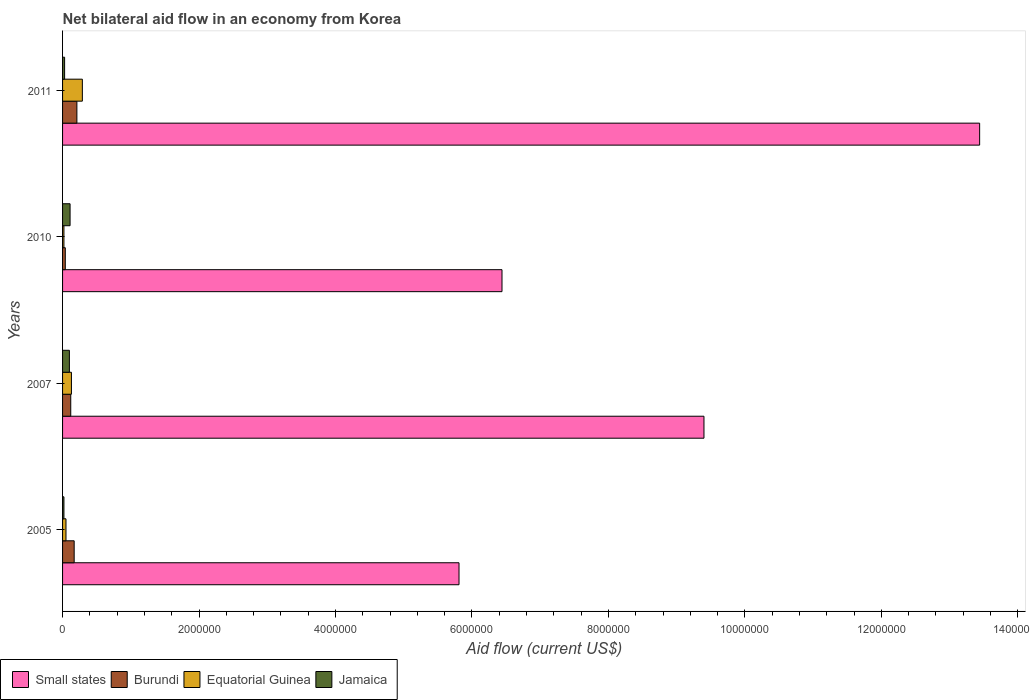How many different coloured bars are there?
Keep it short and to the point. 4. In how many cases, is the number of bars for a given year not equal to the number of legend labels?
Your answer should be compact. 0. What is the net bilateral aid flow in Small states in 2007?
Keep it short and to the point. 9.40e+06. Across all years, what is the maximum net bilateral aid flow in Small states?
Ensure brevity in your answer.  1.34e+07. Across all years, what is the minimum net bilateral aid flow in Burundi?
Your response must be concise. 4.00e+04. In which year was the net bilateral aid flow in Burundi minimum?
Provide a succinct answer. 2010. What is the total net bilateral aid flow in Small states in the graph?
Provide a short and direct response. 3.51e+07. What is the difference between the net bilateral aid flow in Equatorial Guinea in 2005 and that in 2010?
Provide a succinct answer. 3.00e+04. What is the average net bilateral aid flow in Small states per year?
Ensure brevity in your answer.  8.77e+06. What is the ratio of the net bilateral aid flow in Burundi in 2005 to that in 2010?
Keep it short and to the point. 4.25. Is the net bilateral aid flow in Jamaica in 2005 less than that in 2007?
Your answer should be compact. Yes. What is the difference between the highest and the second highest net bilateral aid flow in Jamaica?
Provide a succinct answer. 10000. In how many years, is the net bilateral aid flow in Equatorial Guinea greater than the average net bilateral aid flow in Equatorial Guinea taken over all years?
Offer a very short reply. 2. What does the 2nd bar from the top in 2010 represents?
Keep it short and to the point. Equatorial Guinea. What does the 2nd bar from the bottom in 2010 represents?
Your answer should be very brief. Burundi. Is it the case that in every year, the sum of the net bilateral aid flow in Jamaica and net bilateral aid flow in Small states is greater than the net bilateral aid flow in Equatorial Guinea?
Offer a terse response. Yes. How many bars are there?
Your answer should be compact. 16. Are the values on the major ticks of X-axis written in scientific E-notation?
Ensure brevity in your answer.  No. Does the graph contain any zero values?
Offer a terse response. No. Does the graph contain grids?
Provide a short and direct response. No. How many legend labels are there?
Give a very brief answer. 4. What is the title of the graph?
Your response must be concise. Net bilateral aid flow in an economy from Korea. Does "European Union" appear as one of the legend labels in the graph?
Your answer should be compact. No. What is the label or title of the X-axis?
Keep it short and to the point. Aid flow (current US$). What is the label or title of the Y-axis?
Make the answer very short. Years. What is the Aid flow (current US$) of Small states in 2005?
Ensure brevity in your answer.  5.81e+06. What is the Aid flow (current US$) in Jamaica in 2005?
Your response must be concise. 2.00e+04. What is the Aid flow (current US$) in Small states in 2007?
Offer a terse response. 9.40e+06. What is the Aid flow (current US$) in Burundi in 2007?
Provide a succinct answer. 1.20e+05. What is the Aid flow (current US$) in Equatorial Guinea in 2007?
Your answer should be very brief. 1.30e+05. What is the Aid flow (current US$) in Small states in 2010?
Provide a succinct answer. 6.44e+06. What is the Aid flow (current US$) in Burundi in 2010?
Offer a terse response. 4.00e+04. What is the Aid flow (current US$) of Equatorial Guinea in 2010?
Make the answer very short. 2.00e+04. What is the Aid flow (current US$) in Small states in 2011?
Offer a terse response. 1.34e+07. What is the Aid flow (current US$) in Burundi in 2011?
Provide a succinct answer. 2.10e+05. What is the Aid flow (current US$) of Equatorial Guinea in 2011?
Your answer should be very brief. 2.90e+05. What is the Aid flow (current US$) in Jamaica in 2011?
Give a very brief answer. 3.00e+04. Across all years, what is the maximum Aid flow (current US$) of Small states?
Your answer should be very brief. 1.34e+07. Across all years, what is the maximum Aid flow (current US$) of Equatorial Guinea?
Offer a very short reply. 2.90e+05. Across all years, what is the maximum Aid flow (current US$) in Jamaica?
Make the answer very short. 1.10e+05. Across all years, what is the minimum Aid flow (current US$) in Small states?
Offer a terse response. 5.81e+06. Across all years, what is the minimum Aid flow (current US$) of Jamaica?
Keep it short and to the point. 2.00e+04. What is the total Aid flow (current US$) in Small states in the graph?
Offer a terse response. 3.51e+07. What is the total Aid flow (current US$) of Burundi in the graph?
Your answer should be very brief. 5.40e+05. What is the total Aid flow (current US$) in Jamaica in the graph?
Offer a very short reply. 2.60e+05. What is the difference between the Aid flow (current US$) in Small states in 2005 and that in 2007?
Your response must be concise. -3.59e+06. What is the difference between the Aid flow (current US$) of Equatorial Guinea in 2005 and that in 2007?
Make the answer very short. -8.00e+04. What is the difference between the Aid flow (current US$) of Jamaica in 2005 and that in 2007?
Ensure brevity in your answer.  -8.00e+04. What is the difference between the Aid flow (current US$) of Small states in 2005 and that in 2010?
Keep it short and to the point. -6.30e+05. What is the difference between the Aid flow (current US$) of Burundi in 2005 and that in 2010?
Your answer should be compact. 1.30e+05. What is the difference between the Aid flow (current US$) of Equatorial Guinea in 2005 and that in 2010?
Your response must be concise. 3.00e+04. What is the difference between the Aid flow (current US$) in Jamaica in 2005 and that in 2010?
Give a very brief answer. -9.00e+04. What is the difference between the Aid flow (current US$) of Small states in 2005 and that in 2011?
Give a very brief answer. -7.63e+06. What is the difference between the Aid flow (current US$) of Jamaica in 2005 and that in 2011?
Offer a very short reply. -10000. What is the difference between the Aid flow (current US$) in Small states in 2007 and that in 2010?
Offer a terse response. 2.96e+06. What is the difference between the Aid flow (current US$) in Small states in 2007 and that in 2011?
Keep it short and to the point. -4.04e+06. What is the difference between the Aid flow (current US$) of Burundi in 2007 and that in 2011?
Keep it short and to the point. -9.00e+04. What is the difference between the Aid flow (current US$) in Equatorial Guinea in 2007 and that in 2011?
Keep it short and to the point. -1.60e+05. What is the difference between the Aid flow (current US$) of Small states in 2010 and that in 2011?
Offer a very short reply. -7.00e+06. What is the difference between the Aid flow (current US$) in Burundi in 2010 and that in 2011?
Make the answer very short. -1.70e+05. What is the difference between the Aid flow (current US$) of Equatorial Guinea in 2010 and that in 2011?
Give a very brief answer. -2.70e+05. What is the difference between the Aid flow (current US$) of Jamaica in 2010 and that in 2011?
Give a very brief answer. 8.00e+04. What is the difference between the Aid flow (current US$) in Small states in 2005 and the Aid flow (current US$) in Burundi in 2007?
Offer a terse response. 5.69e+06. What is the difference between the Aid flow (current US$) in Small states in 2005 and the Aid flow (current US$) in Equatorial Guinea in 2007?
Your answer should be very brief. 5.68e+06. What is the difference between the Aid flow (current US$) of Small states in 2005 and the Aid flow (current US$) of Jamaica in 2007?
Provide a succinct answer. 5.71e+06. What is the difference between the Aid flow (current US$) in Burundi in 2005 and the Aid flow (current US$) in Jamaica in 2007?
Ensure brevity in your answer.  7.00e+04. What is the difference between the Aid flow (current US$) in Equatorial Guinea in 2005 and the Aid flow (current US$) in Jamaica in 2007?
Ensure brevity in your answer.  -5.00e+04. What is the difference between the Aid flow (current US$) in Small states in 2005 and the Aid flow (current US$) in Burundi in 2010?
Offer a terse response. 5.77e+06. What is the difference between the Aid flow (current US$) in Small states in 2005 and the Aid flow (current US$) in Equatorial Guinea in 2010?
Provide a short and direct response. 5.79e+06. What is the difference between the Aid flow (current US$) of Small states in 2005 and the Aid flow (current US$) of Jamaica in 2010?
Keep it short and to the point. 5.70e+06. What is the difference between the Aid flow (current US$) in Equatorial Guinea in 2005 and the Aid flow (current US$) in Jamaica in 2010?
Keep it short and to the point. -6.00e+04. What is the difference between the Aid flow (current US$) in Small states in 2005 and the Aid flow (current US$) in Burundi in 2011?
Offer a terse response. 5.60e+06. What is the difference between the Aid flow (current US$) of Small states in 2005 and the Aid flow (current US$) of Equatorial Guinea in 2011?
Provide a short and direct response. 5.52e+06. What is the difference between the Aid flow (current US$) of Small states in 2005 and the Aid flow (current US$) of Jamaica in 2011?
Offer a terse response. 5.78e+06. What is the difference between the Aid flow (current US$) in Small states in 2007 and the Aid flow (current US$) in Burundi in 2010?
Your response must be concise. 9.36e+06. What is the difference between the Aid flow (current US$) in Small states in 2007 and the Aid flow (current US$) in Equatorial Guinea in 2010?
Your answer should be very brief. 9.38e+06. What is the difference between the Aid flow (current US$) of Small states in 2007 and the Aid flow (current US$) of Jamaica in 2010?
Offer a terse response. 9.29e+06. What is the difference between the Aid flow (current US$) of Small states in 2007 and the Aid flow (current US$) of Burundi in 2011?
Offer a very short reply. 9.19e+06. What is the difference between the Aid flow (current US$) of Small states in 2007 and the Aid flow (current US$) of Equatorial Guinea in 2011?
Your answer should be compact. 9.11e+06. What is the difference between the Aid flow (current US$) in Small states in 2007 and the Aid flow (current US$) in Jamaica in 2011?
Keep it short and to the point. 9.37e+06. What is the difference between the Aid flow (current US$) in Equatorial Guinea in 2007 and the Aid flow (current US$) in Jamaica in 2011?
Offer a terse response. 1.00e+05. What is the difference between the Aid flow (current US$) in Small states in 2010 and the Aid flow (current US$) in Burundi in 2011?
Offer a terse response. 6.23e+06. What is the difference between the Aid flow (current US$) of Small states in 2010 and the Aid flow (current US$) of Equatorial Guinea in 2011?
Keep it short and to the point. 6.15e+06. What is the difference between the Aid flow (current US$) in Small states in 2010 and the Aid flow (current US$) in Jamaica in 2011?
Ensure brevity in your answer.  6.41e+06. What is the difference between the Aid flow (current US$) of Equatorial Guinea in 2010 and the Aid flow (current US$) of Jamaica in 2011?
Offer a very short reply. -10000. What is the average Aid flow (current US$) of Small states per year?
Your answer should be compact. 8.77e+06. What is the average Aid flow (current US$) in Burundi per year?
Offer a very short reply. 1.35e+05. What is the average Aid flow (current US$) in Equatorial Guinea per year?
Your response must be concise. 1.22e+05. What is the average Aid flow (current US$) of Jamaica per year?
Make the answer very short. 6.50e+04. In the year 2005, what is the difference between the Aid flow (current US$) in Small states and Aid flow (current US$) in Burundi?
Offer a very short reply. 5.64e+06. In the year 2005, what is the difference between the Aid flow (current US$) of Small states and Aid flow (current US$) of Equatorial Guinea?
Give a very brief answer. 5.76e+06. In the year 2005, what is the difference between the Aid flow (current US$) of Small states and Aid flow (current US$) of Jamaica?
Provide a short and direct response. 5.79e+06. In the year 2007, what is the difference between the Aid flow (current US$) in Small states and Aid flow (current US$) in Burundi?
Provide a short and direct response. 9.28e+06. In the year 2007, what is the difference between the Aid flow (current US$) in Small states and Aid flow (current US$) in Equatorial Guinea?
Provide a succinct answer. 9.27e+06. In the year 2007, what is the difference between the Aid flow (current US$) in Small states and Aid flow (current US$) in Jamaica?
Provide a short and direct response. 9.30e+06. In the year 2007, what is the difference between the Aid flow (current US$) of Burundi and Aid flow (current US$) of Equatorial Guinea?
Provide a succinct answer. -10000. In the year 2007, what is the difference between the Aid flow (current US$) in Burundi and Aid flow (current US$) in Jamaica?
Make the answer very short. 2.00e+04. In the year 2010, what is the difference between the Aid flow (current US$) of Small states and Aid flow (current US$) of Burundi?
Make the answer very short. 6.40e+06. In the year 2010, what is the difference between the Aid flow (current US$) of Small states and Aid flow (current US$) of Equatorial Guinea?
Your answer should be very brief. 6.42e+06. In the year 2010, what is the difference between the Aid flow (current US$) in Small states and Aid flow (current US$) in Jamaica?
Give a very brief answer. 6.33e+06. In the year 2010, what is the difference between the Aid flow (current US$) of Equatorial Guinea and Aid flow (current US$) of Jamaica?
Your response must be concise. -9.00e+04. In the year 2011, what is the difference between the Aid flow (current US$) in Small states and Aid flow (current US$) in Burundi?
Provide a short and direct response. 1.32e+07. In the year 2011, what is the difference between the Aid flow (current US$) in Small states and Aid flow (current US$) in Equatorial Guinea?
Ensure brevity in your answer.  1.32e+07. In the year 2011, what is the difference between the Aid flow (current US$) of Small states and Aid flow (current US$) of Jamaica?
Your response must be concise. 1.34e+07. In the year 2011, what is the difference between the Aid flow (current US$) in Burundi and Aid flow (current US$) in Jamaica?
Your answer should be compact. 1.80e+05. In the year 2011, what is the difference between the Aid flow (current US$) in Equatorial Guinea and Aid flow (current US$) in Jamaica?
Ensure brevity in your answer.  2.60e+05. What is the ratio of the Aid flow (current US$) in Small states in 2005 to that in 2007?
Provide a succinct answer. 0.62. What is the ratio of the Aid flow (current US$) in Burundi in 2005 to that in 2007?
Offer a terse response. 1.42. What is the ratio of the Aid flow (current US$) in Equatorial Guinea in 2005 to that in 2007?
Offer a very short reply. 0.38. What is the ratio of the Aid flow (current US$) of Small states in 2005 to that in 2010?
Provide a short and direct response. 0.9. What is the ratio of the Aid flow (current US$) of Burundi in 2005 to that in 2010?
Give a very brief answer. 4.25. What is the ratio of the Aid flow (current US$) of Equatorial Guinea in 2005 to that in 2010?
Your response must be concise. 2.5. What is the ratio of the Aid flow (current US$) in Jamaica in 2005 to that in 2010?
Keep it short and to the point. 0.18. What is the ratio of the Aid flow (current US$) in Small states in 2005 to that in 2011?
Your answer should be compact. 0.43. What is the ratio of the Aid flow (current US$) of Burundi in 2005 to that in 2011?
Give a very brief answer. 0.81. What is the ratio of the Aid flow (current US$) in Equatorial Guinea in 2005 to that in 2011?
Offer a very short reply. 0.17. What is the ratio of the Aid flow (current US$) in Small states in 2007 to that in 2010?
Make the answer very short. 1.46. What is the ratio of the Aid flow (current US$) in Jamaica in 2007 to that in 2010?
Your answer should be very brief. 0.91. What is the ratio of the Aid flow (current US$) in Small states in 2007 to that in 2011?
Give a very brief answer. 0.7. What is the ratio of the Aid flow (current US$) of Equatorial Guinea in 2007 to that in 2011?
Keep it short and to the point. 0.45. What is the ratio of the Aid flow (current US$) of Small states in 2010 to that in 2011?
Provide a short and direct response. 0.48. What is the ratio of the Aid flow (current US$) in Burundi in 2010 to that in 2011?
Your answer should be very brief. 0.19. What is the ratio of the Aid flow (current US$) in Equatorial Guinea in 2010 to that in 2011?
Make the answer very short. 0.07. What is the ratio of the Aid flow (current US$) of Jamaica in 2010 to that in 2011?
Ensure brevity in your answer.  3.67. What is the difference between the highest and the second highest Aid flow (current US$) in Small states?
Your answer should be compact. 4.04e+06. What is the difference between the highest and the lowest Aid flow (current US$) of Small states?
Make the answer very short. 7.63e+06. What is the difference between the highest and the lowest Aid flow (current US$) of Burundi?
Your answer should be very brief. 1.70e+05. What is the difference between the highest and the lowest Aid flow (current US$) of Equatorial Guinea?
Provide a succinct answer. 2.70e+05. What is the difference between the highest and the lowest Aid flow (current US$) in Jamaica?
Offer a very short reply. 9.00e+04. 